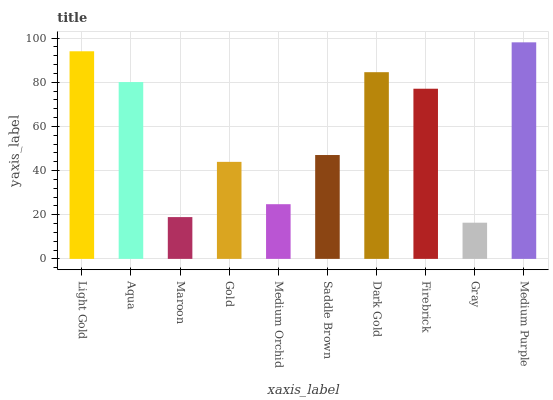Is Gray the minimum?
Answer yes or no. Yes. Is Medium Purple the maximum?
Answer yes or no. Yes. Is Aqua the minimum?
Answer yes or no. No. Is Aqua the maximum?
Answer yes or no. No. Is Light Gold greater than Aqua?
Answer yes or no. Yes. Is Aqua less than Light Gold?
Answer yes or no. Yes. Is Aqua greater than Light Gold?
Answer yes or no. No. Is Light Gold less than Aqua?
Answer yes or no. No. Is Firebrick the high median?
Answer yes or no. Yes. Is Saddle Brown the low median?
Answer yes or no. Yes. Is Dark Gold the high median?
Answer yes or no. No. Is Firebrick the low median?
Answer yes or no. No. 